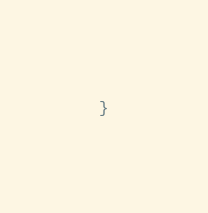<code> <loc_0><loc_0><loc_500><loc_500><_Kotlin_>}
</code> 